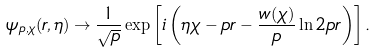<formula> <loc_0><loc_0><loc_500><loc_500>\psi _ { p , \chi } ( r , \eta ) \rightarrow \frac { 1 } { \sqrt { p } } \exp \left [ i \left ( \eta \chi - p r - \frac { w ( \chi ) } { p } \ln 2 p r \right ) \right ] .</formula> 